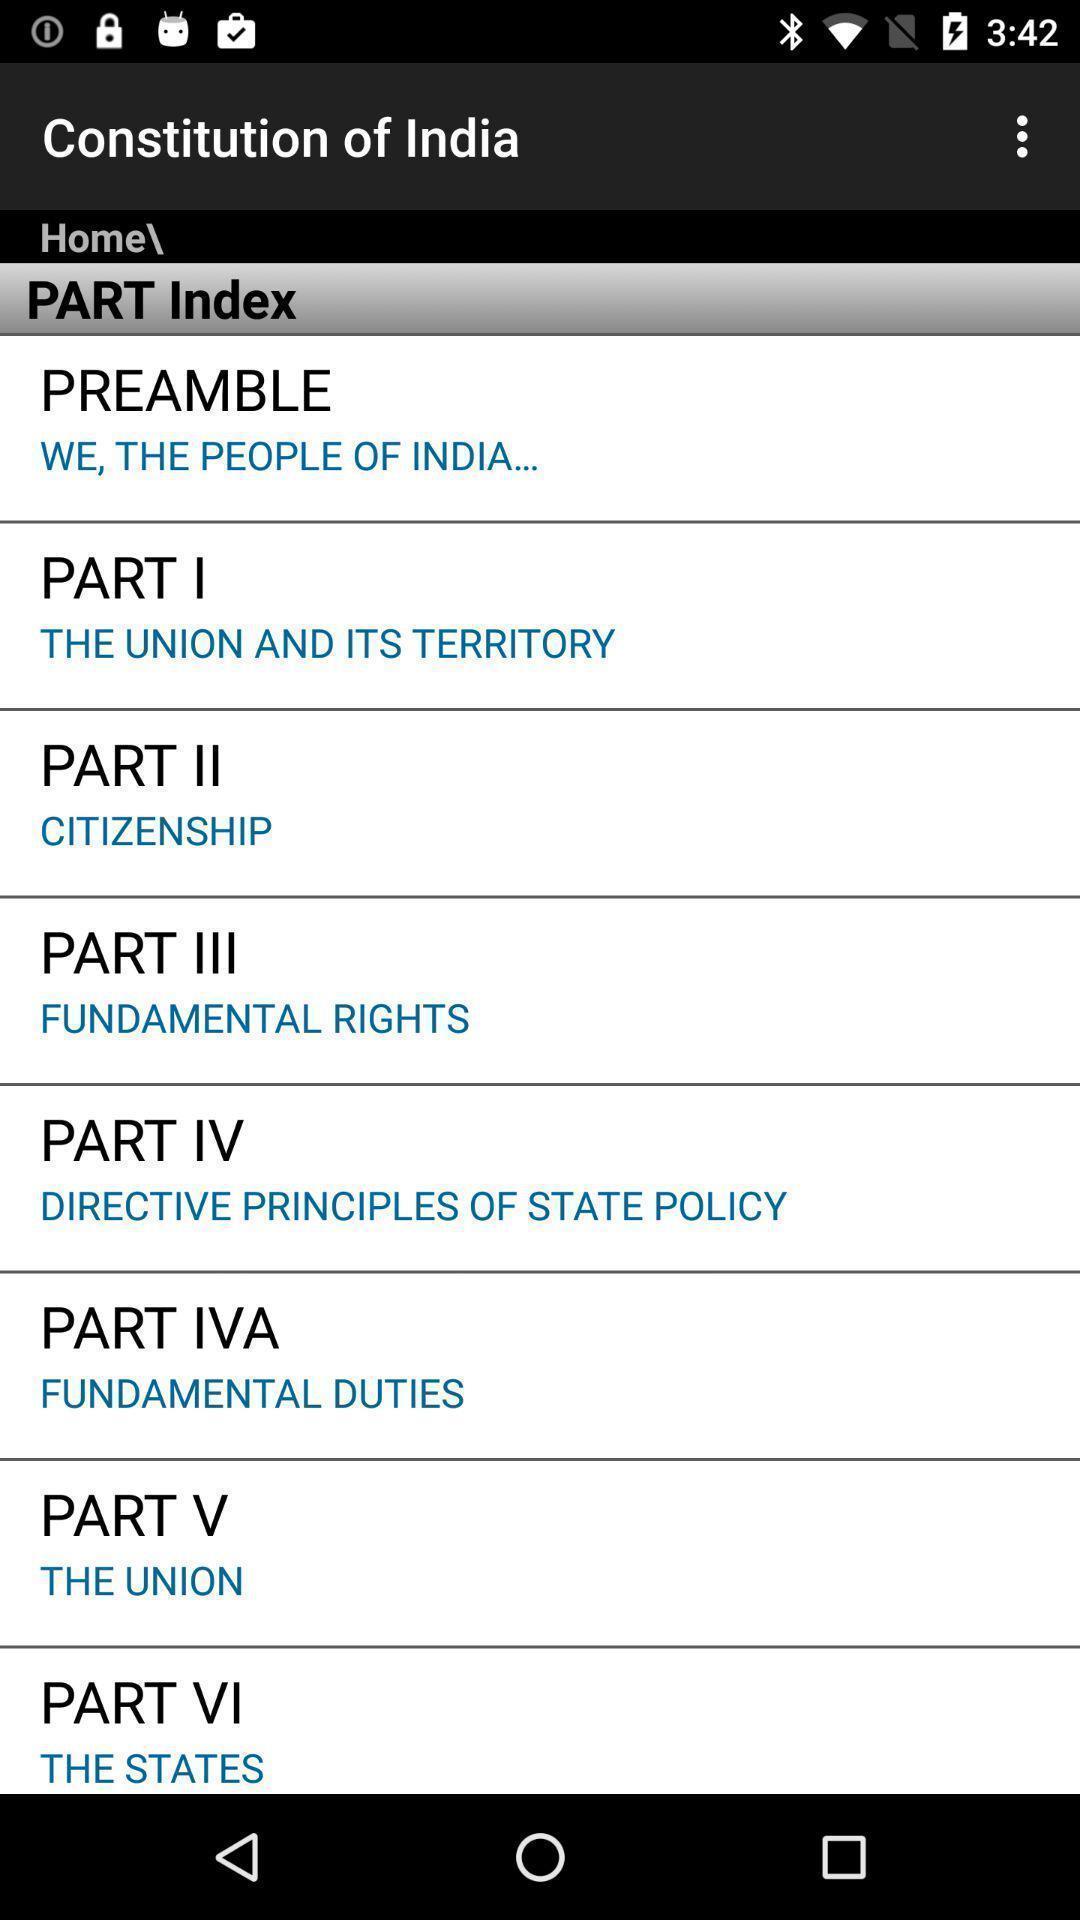Describe the visual elements of this screenshot. Page displays list of parts regarding constitution in app. 